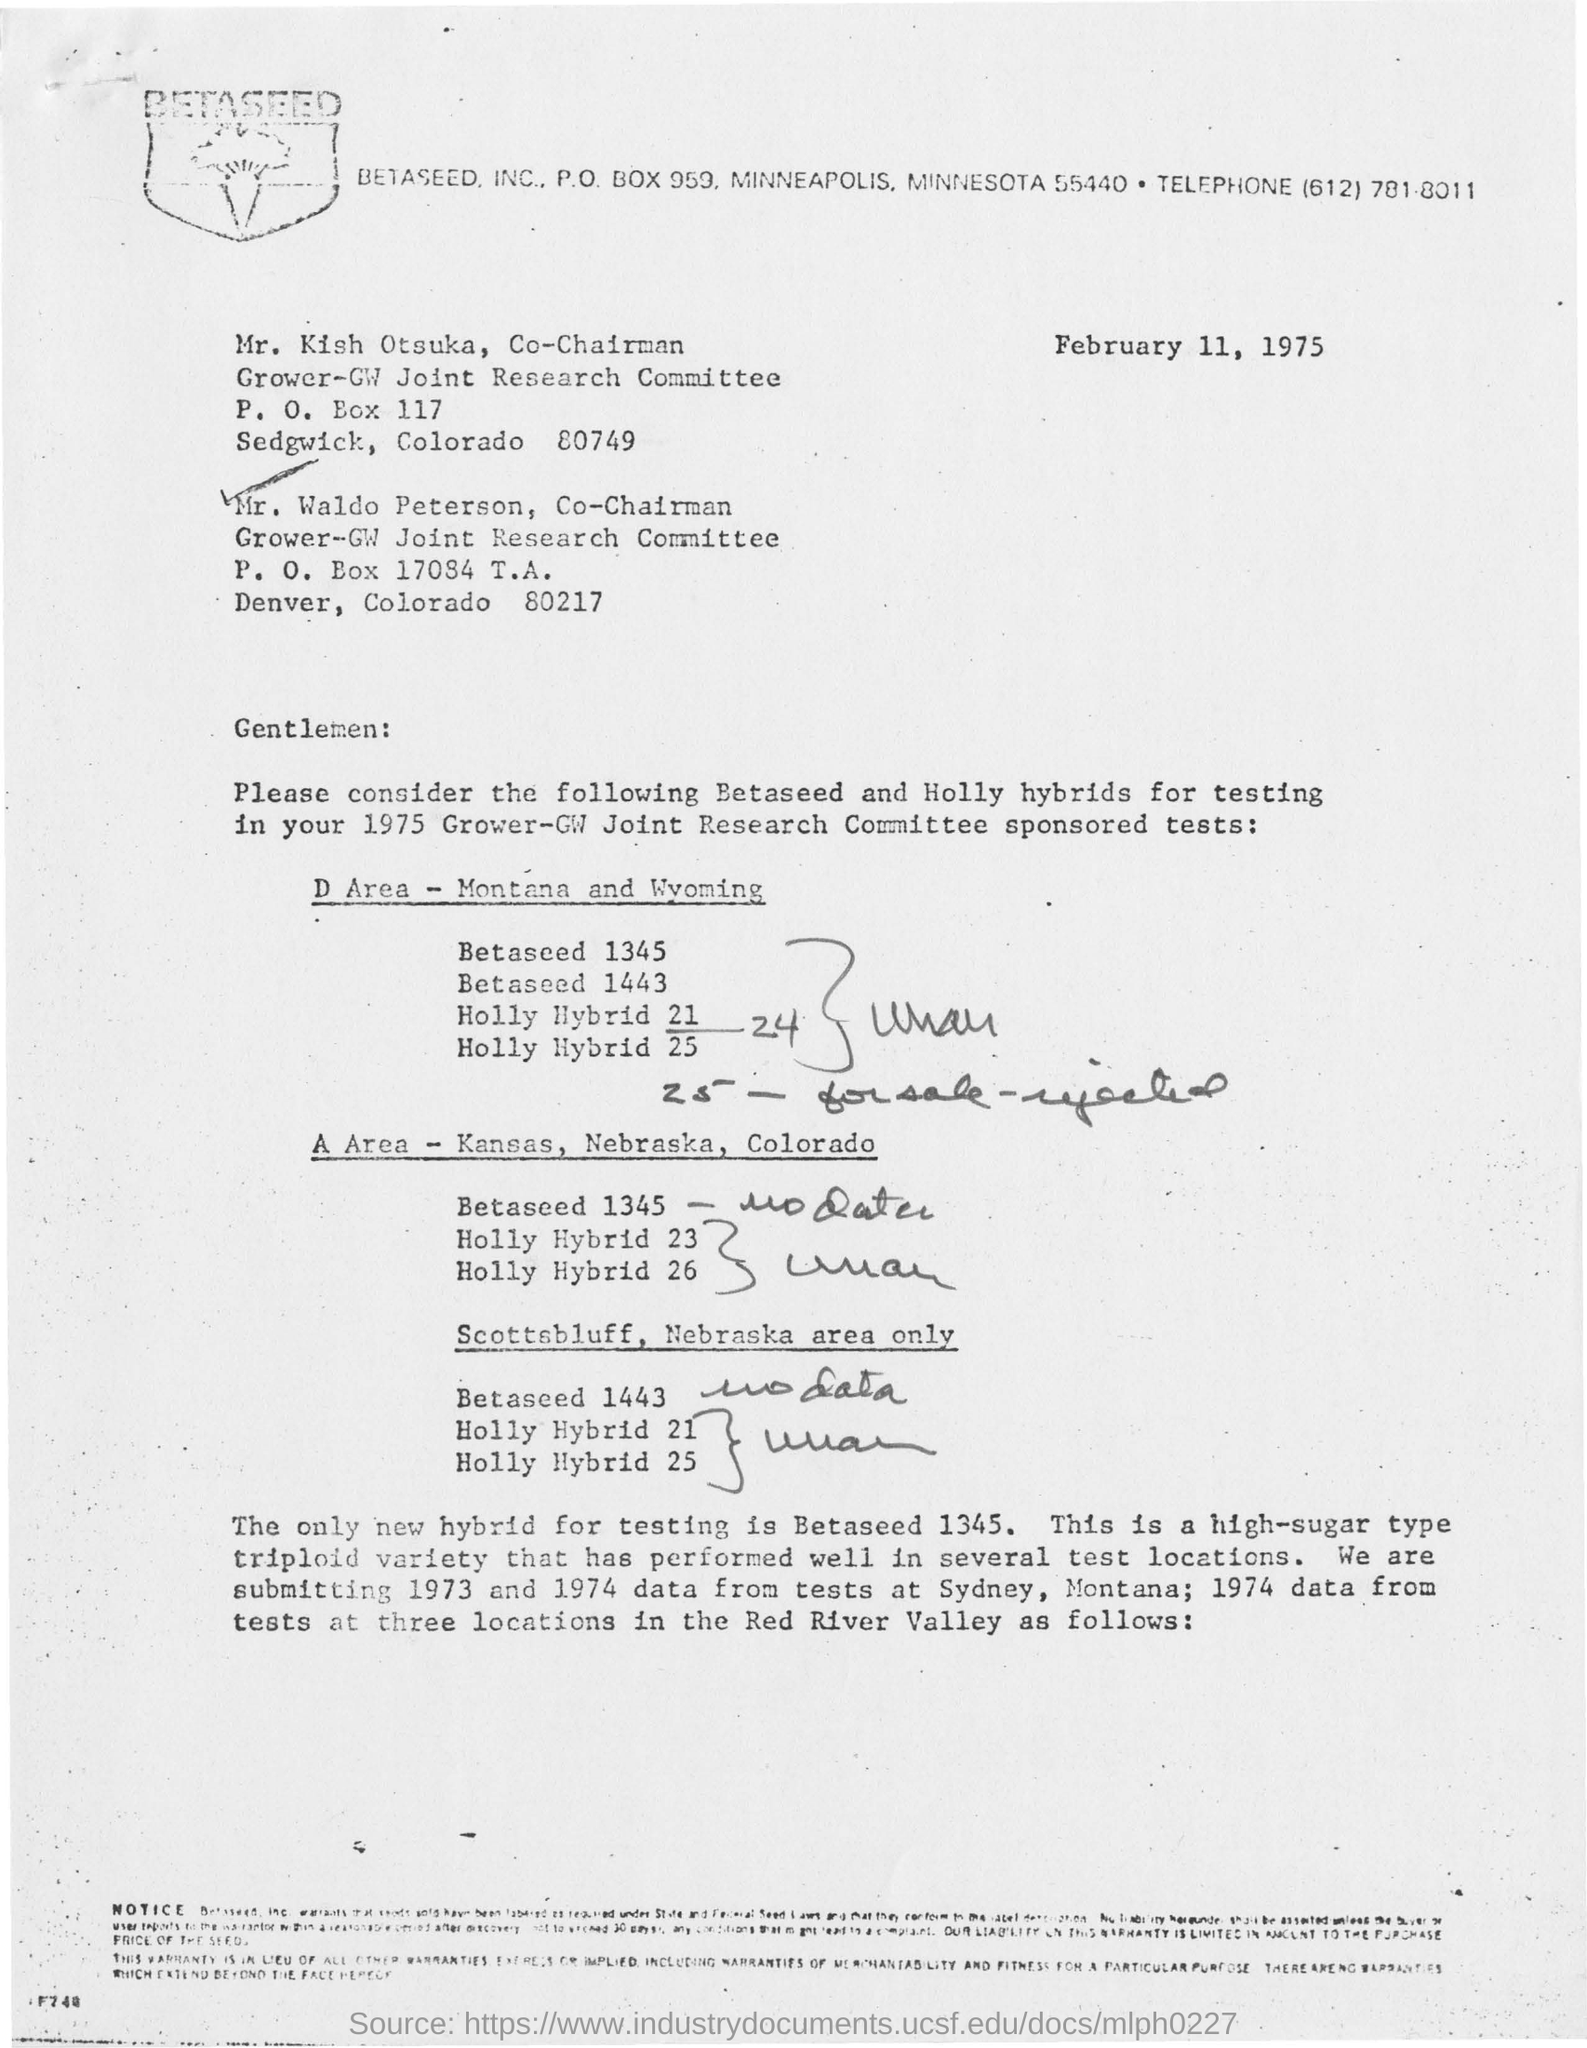Specify some key components in this picture. The letterhead mentions BETASEED, INC. The company's post box number is 959. Kish Otsuka holds the designation of Co-Chairman. February 11, 1975 is the date mentioned in the document. Mr. Waldo Peterson holds the designation of Co-Chairman. 